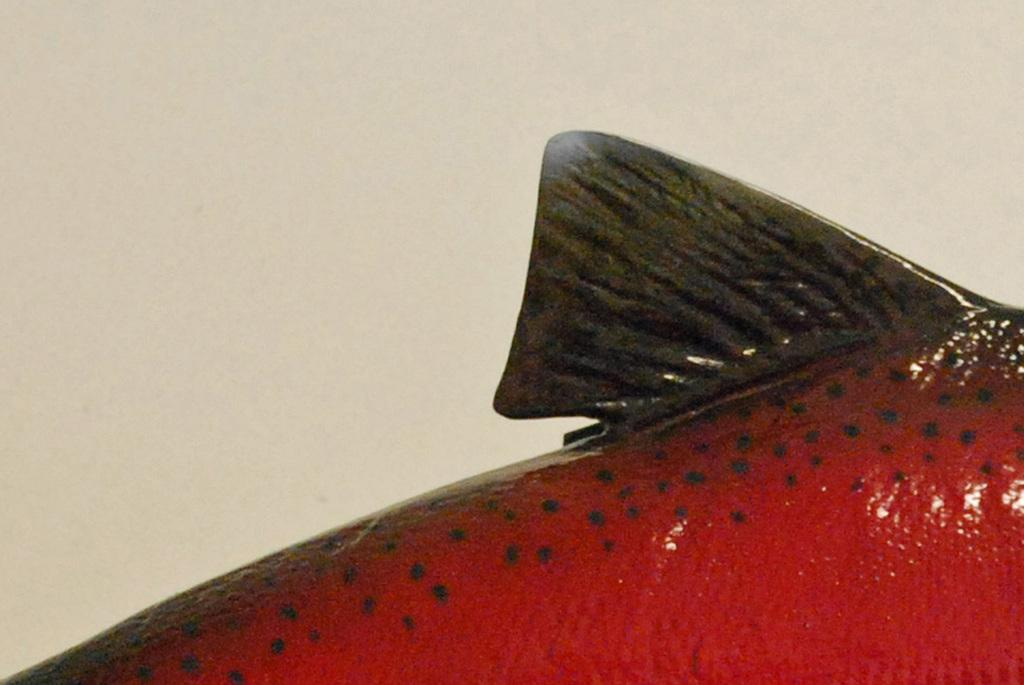What type of animal is at the bottom of the image? There is a red fish at the bottom of the image. What is located at the top of the image? There is a wall at the top of the image. What type of cave can be seen in the image? There is no cave present in the image; it features a red fish at the bottom and a wall at the top. What kind of cork is used to seal the soda bottle in the image? There is no soda bottle or cork present in the image. 